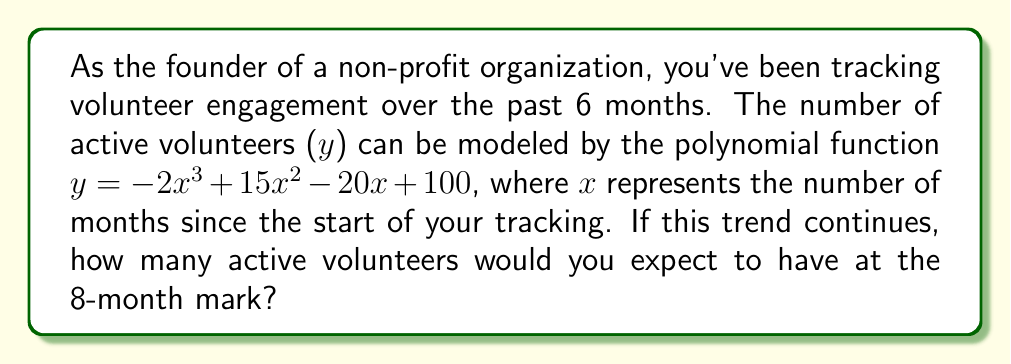Give your solution to this math problem. To solve this problem, we need to follow these steps:

1) We are given the polynomial function:
   $y = -2x^3 + 15x^2 - 20x + 100$

2) We need to find y when x = 8 (8 months):
   $y = -2(8)^3 + 15(8)^2 - 20(8) + 100$

3) Let's calculate each term:
   $-2(8)^3 = -2(512) = -1024$
   $15(8)^2 = 15(64) = 960$
   $-20(8) = -160$
   $100$ remains as is

4) Now, let's sum all these terms:
   $y = -1024 + 960 - 160 + 100$

5) Simplifying:
   $y = -124$

However, since we're dealing with the number of volunteers, a negative value doesn't make sense in this context. This suggests that our polynomial model is not accurate for predicting volunteer numbers beyond the 6-month period for which it was originally fitted.

In a real-world scenario, we would need to reassess our model or limit its application to the original 6-month period. For the purpose of this mathematical exercise, we'll consider the calculated value as the theoretical result of the given function.
Answer: -124 volunteers (theoretical result, not practically applicable) 